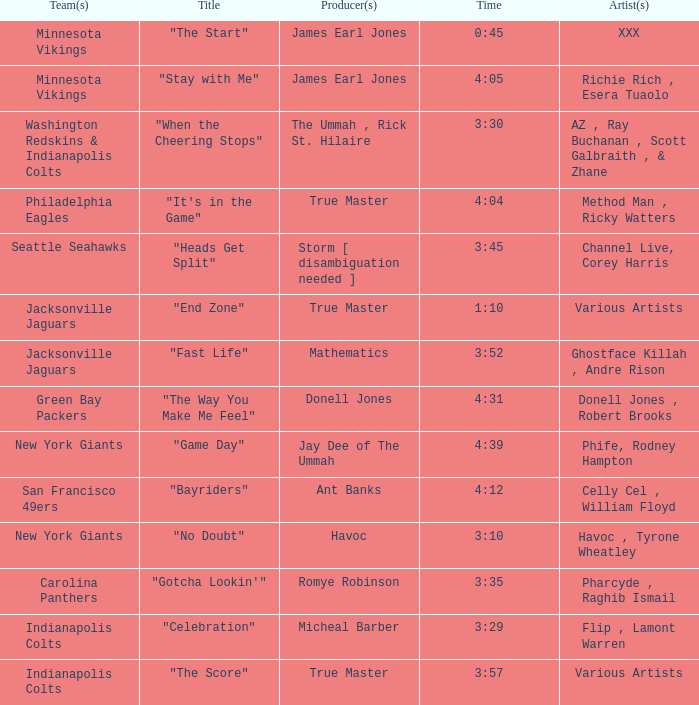How long is the XXX track used by the Minnesota Vikings? 0:45. 